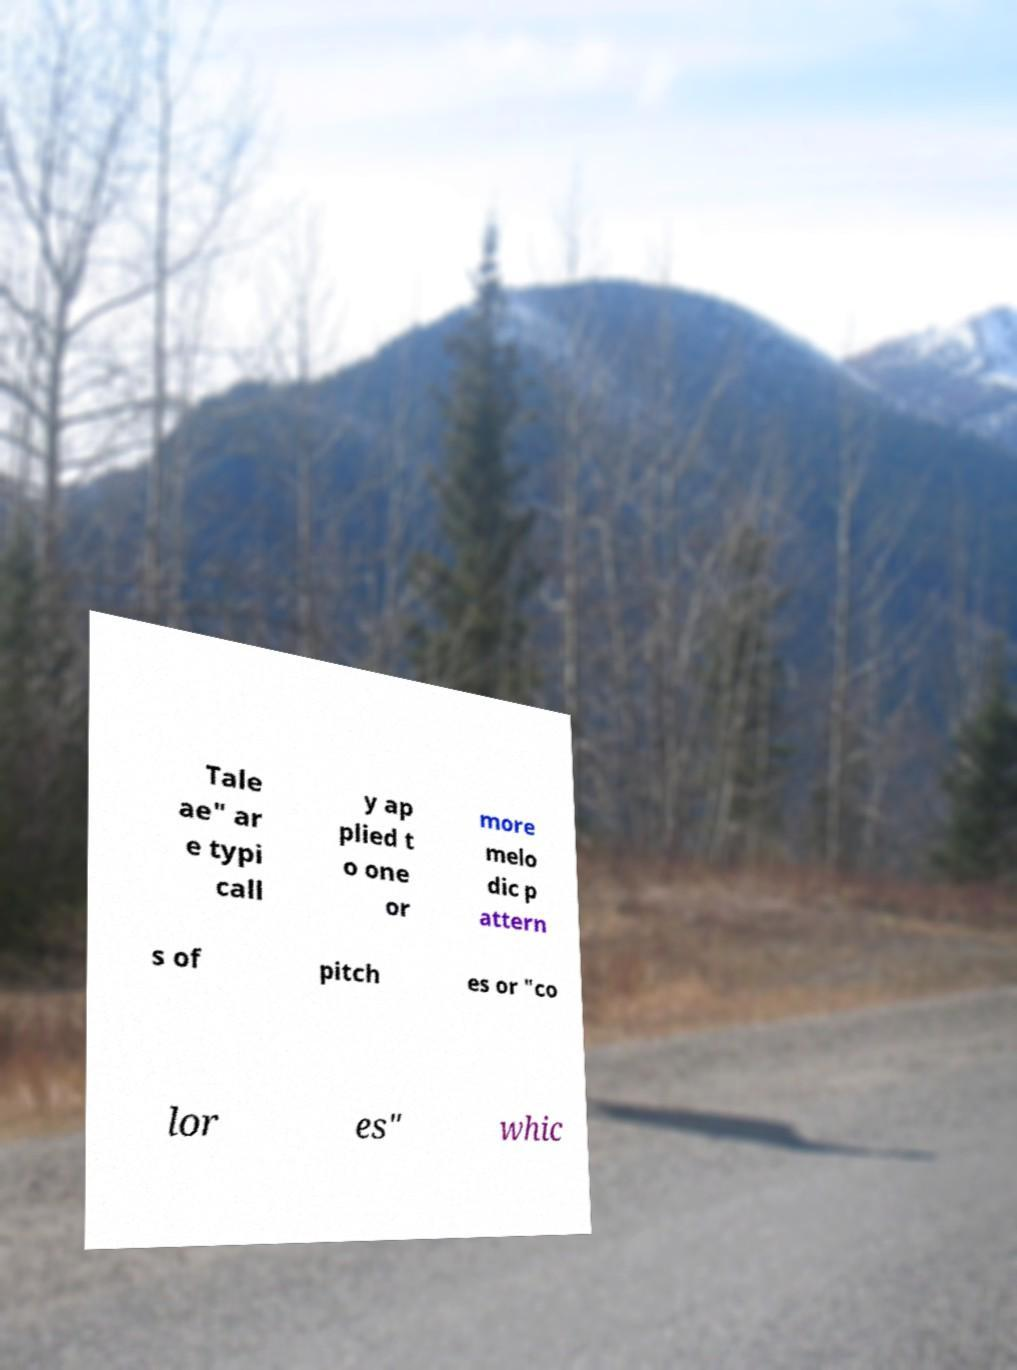Could you assist in decoding the text presented in this image and type it out clearly? Tale ae" ar e typi call y ap plied t o one or more melo dic p attern s of pitch es or "co lor es" whic 